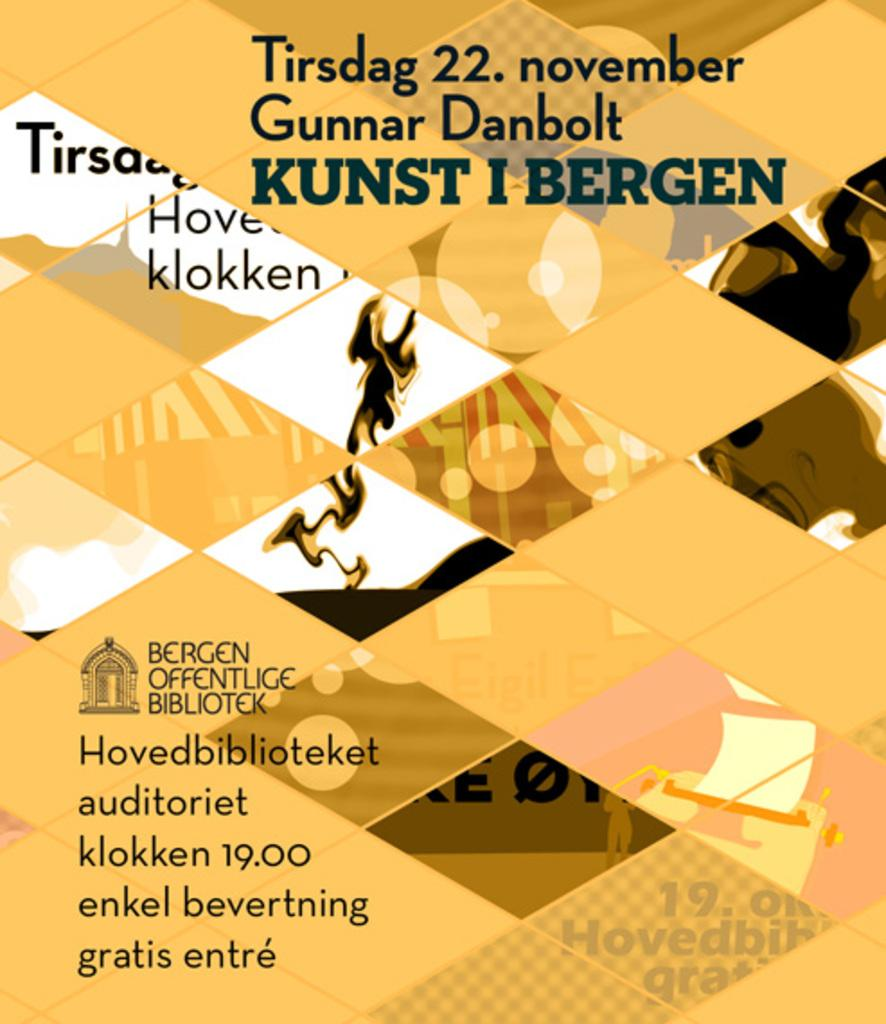<image>
Write a terse but informative summary of the picture. A yellow poster for the 22 of November by the Bergen Offentlige Bibliotek. 